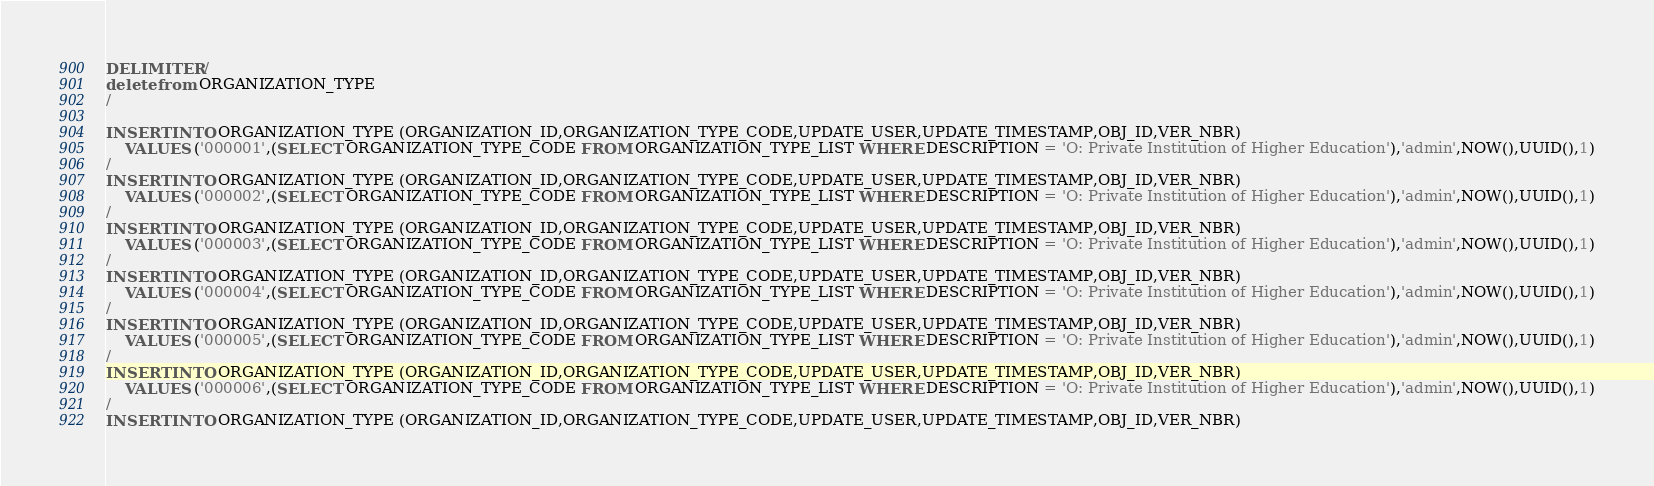Convert code to text. <code><loc_0><loc_0><loc_500><loc_500><_SQL_>DELIMITER /
delete from ORGANIZATION_TYPE
/

INSERT INTO ORGANIZATION_TYPE (ORGANIZATION_ID,ORGANIZATION_TYPE_CODE,UPDATE_USER,UPDATE_TIMESTAMP,OBJ_ID,VER_NBR) 
    VALUES ('000001',(SELECT ORGANIZATION_TYPE_CODE FROM ORGANIZATION_TYPE_LIST WHERE DESCRIPTION = 'O: Private Institution of Higher Education'),'admin',NOW(),UUID(),1)
/
INSERT INTO ORGANIZATION_TYPE (ORGANIZATION_ID,ORGANIZATION_TYPE_CODE,UPDATE_USER,UPDATE_TIMESTAMP,OBJ_ID,VER_NBR) 
    VALUES ('000002',(SELECT ORGANIZATION_TYPE_CODE FROM ORGANIZATION_TYPE_LIST WHERE DESCRIPTION = 'O: Private Institution of Higher Education'),'admin',NOW(),UUID(),1)
/
INSERT INTO ORGANIZATION_TYPE (ORGANIZATION_ID,ORGANIZATION_TYPE_CODE,UPDATE_USER,UPDATE_TIMESTAMP,OBJ_ID,VER_NBR) 
    VALUES ('000003',(SELECT ORGANIZATION_TYPE_CODE FROM ORGANIZATION_TYPE_LIST WHERE DESCRIPTION = 'O: Private Institution of Higher Education'),'admin',NOW(),UUID(),1)
/
INSERT INTO ORGANIZATION_TYPE (ORGANIZATION_ID,ORGANIZATION_TYPE_CODE,UPDATE_USER,UPDATE_TIMESTAMP,OBJ_ID,VER_NBR) 
    VALUES ('000004',(SELECT ORGANIZATION_TYPE_CODE FROM ORGANIZATION_TYPE_LIST WHERE DESCRIPTION = 'O: Private Institution of Higher Education'),'admin',NOW(),UUID(),1)
/
INSERT INTO ORGANIZATION_TYPE (ORGANIZATION_ID,ORGANIZATION_TYPE_CODE,UPDATE_USER,UPDATE_TIMESTAMP,OBJ_ID,VER_NBR) 
    VALUES ('000005',(SELECT ORGANIZATION_TYPE_CODE FROM ORGANIZATION_TYPE_LIST WHERE DESCRIPTION = 'O: Private Institution of Higher Education'),'admin',NOW(),UUID(),1)
/
INSERT INTO ORGANIZATION_TYPE (ORGANIZATION_ID,ORGANIZATION_TYPE_CODE,UPDATE_USER,UPDATE_TIMESTAMP,OBJ_ID,VER_NBR) 
    VALUES ('000006',(SELECT ORGANIZATION_TYPE_CODE FROM ORGANIZATION_TYPE_LIST WHERE DESCRIPTION = 'O: Private Institution of Higher Education'),'admin',NOW(),UUID(),1)
/
INSERT INTO ORGANIZATION_TYPE (ORGANIZATION_ID,ORGANIZATION_TYPE_CODE,UPDATE_USER,UPDATE_TIMESTAMP,OBJ_ID,VER_NBR) </code> 